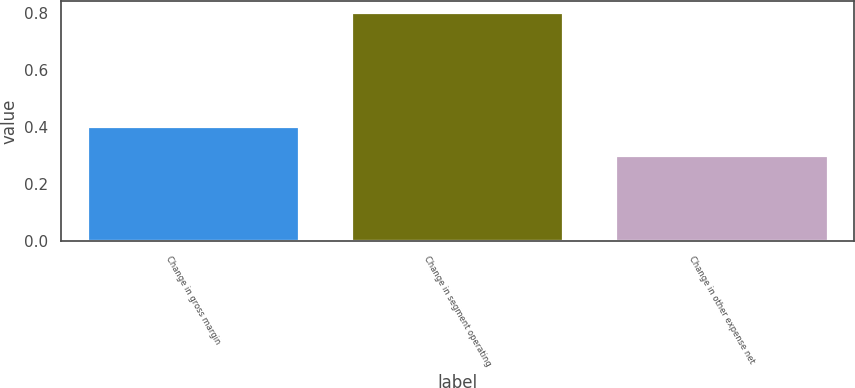<chart> <loc_0><loc_0><loc_500><loc_500><bar_chart><fcel>Change in gross margin<fcel>Change in segment operating<fcel>Change in other expense net<nl><fcel>0.4<fcel>0.8<fcel>0.3<nl></chart> 